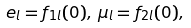Convert formula to latex. <formula><loc_0><loc_0><loc_500><loc_500>e _ { l } = f _ { 1 l } ( 0 ) , \, \mu _ { l } = f _ { 2 l } ( 0 ) ,</formula> 